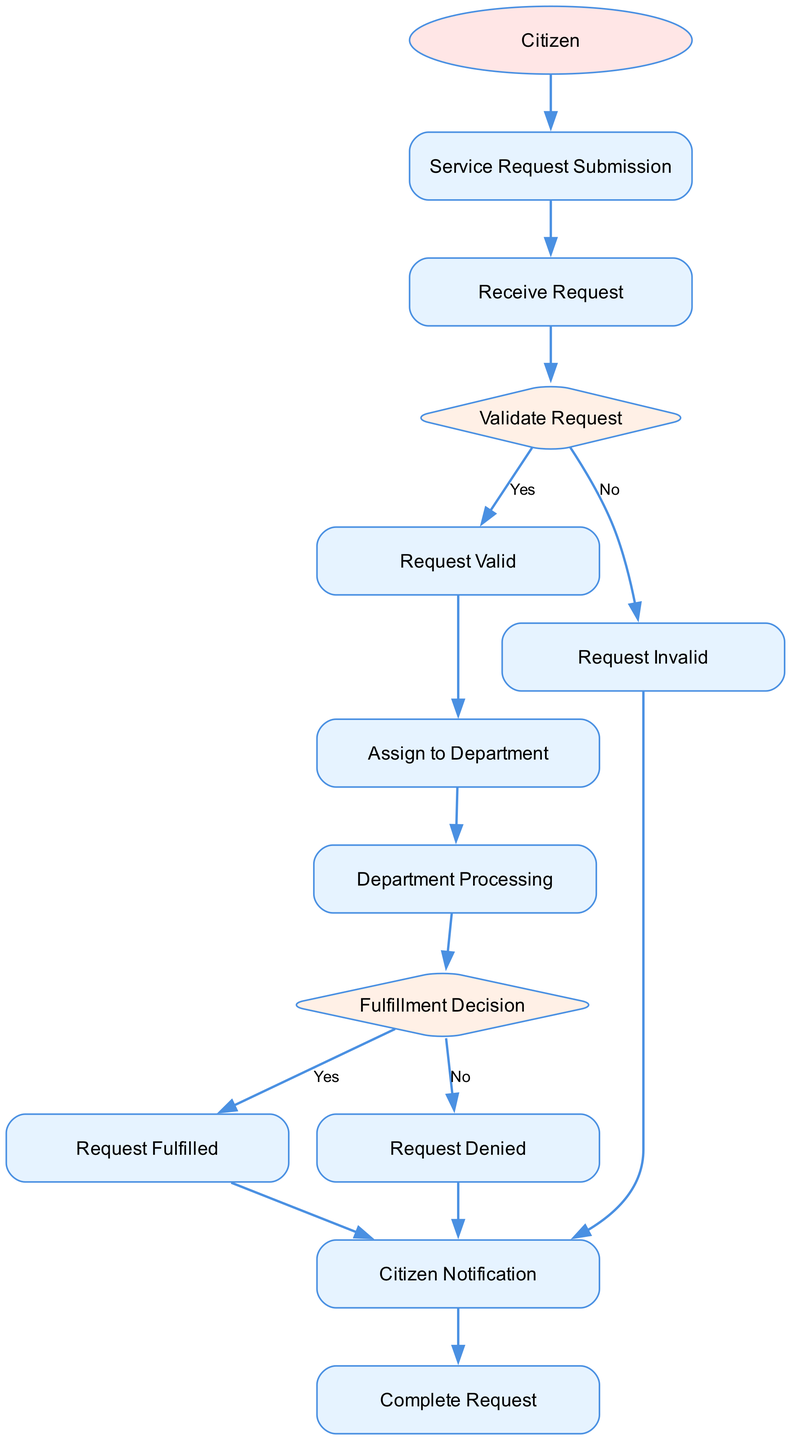What is the first activity in the diagram? The diagram starts with the actor 'Citizen', who initiates the process by submitting a service request through the 'Service Request Submission' activity.
Answer: Service Request Submission How many decision points are present in the diagram? The diagram contains two decision points: one for validating the request and another for fulfilling the request. Thus, there are two decision nodes in total.
Answer: 2 What happens if the request is invalid? If the request is invalid, the flow leads to the 'Request Invalid' activity, where the citizen is notified to provide additional information.
Answer: Notify citizen Which activity follows after the 'Citizen Notification'? After the 'Citizen Notification', the next activity in the flow is 'Complete Request', where the system marks the request as complete.
Answer: Complete Request What is the purpose of the 'Fulfillment Decision' node? The 'Fulfillment Decision' node determines whether the request can be fulfilled based on the processing results from the assigned department.
Answer: Determine fulfillment Which actor is involved in the initial stage of the process? The citizen is the actor involved in the initial stage, as they are the ones submitting the service request.
Answer: Citizen What occurs after the 'Assign to Department' activity? Following the 'Assign to Department' activity, the flow moves to 'Department Processing', where the appropriate government department handles the request.
Answer: Department Processing What is the next step if the request is valid? If the request is valid, the next step is 'Assign to Department', where the valid request is directed to the relevant department for processing.
Answer: Assign to Department What does the 'Request Fulfilled' activity signify? The 'Request Fulfilled' activity signifies that the service request has been successfully completed and the results have been sent to the citizen.
Answer: Service request fulfilled 